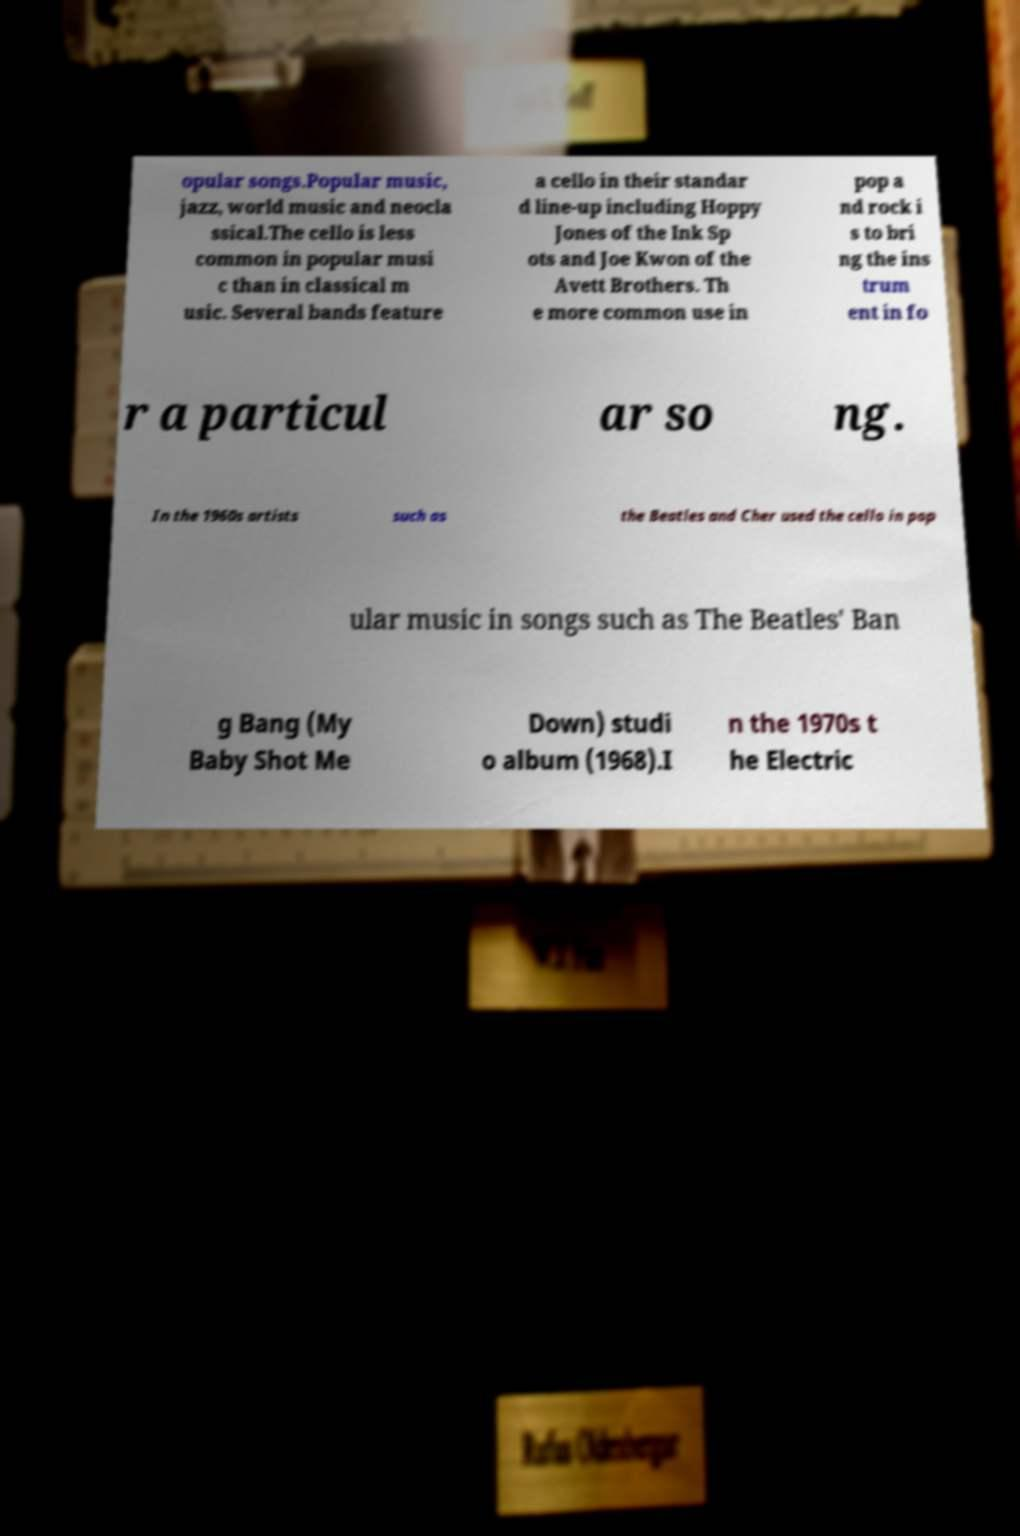I need the written content from this picture converted into text. Can you do that? opular songs.Popular music, jazz, world music and neocla ssical.The cello is less common in popular musi c than in classical m usic. Several bands feature a cello in their standar d line-up including Hoppy Jones of the Ink Sp ots and Joe Kwon of the Avett Brothers. Th e more common use in pop a nd rock i s to bri ng the ins trum ent in fo r a particul ar so ng. In the 1960s artists such as the Beatles and Cher used the cello in pop ular music in songs such as The Beatles' Ban g Bang (My Baby Shot Me Down) studi o album (1968).I n the 1970s t he Electric 